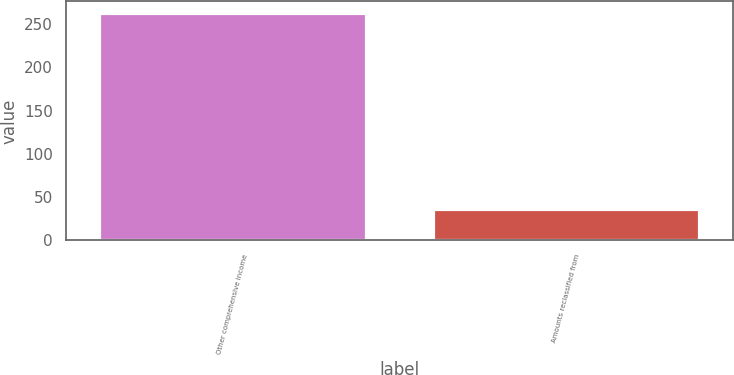Convert chart. <chart><loc_0><loc_0><loc_500><loc_500><bar_chart><fcel>Other comprehensive income<fcel>Amounts reclassified from<nl><fcel>263<fcel>36<nl></chart> 